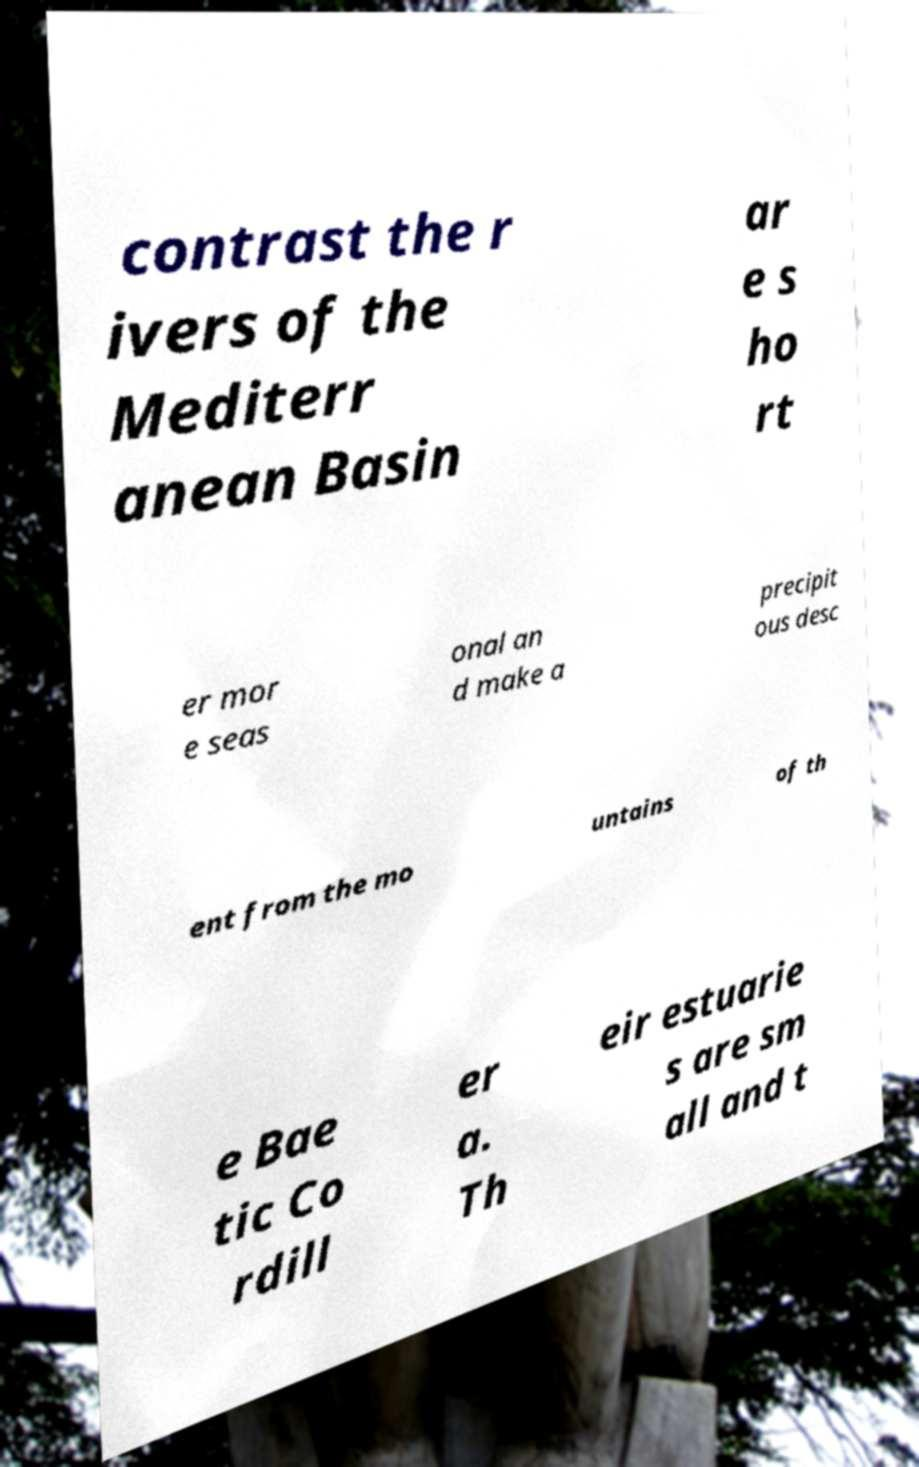Please read and relay the text visible in this image. What does it say? contrast the r ivers of the Mediterr anean Basin ar e s ho rt er mor e seas onal an d make a precipit ous desc ent from the mo untains of th e Bae tic Co rdill er a. Th eir estuarie s are sm all and t 